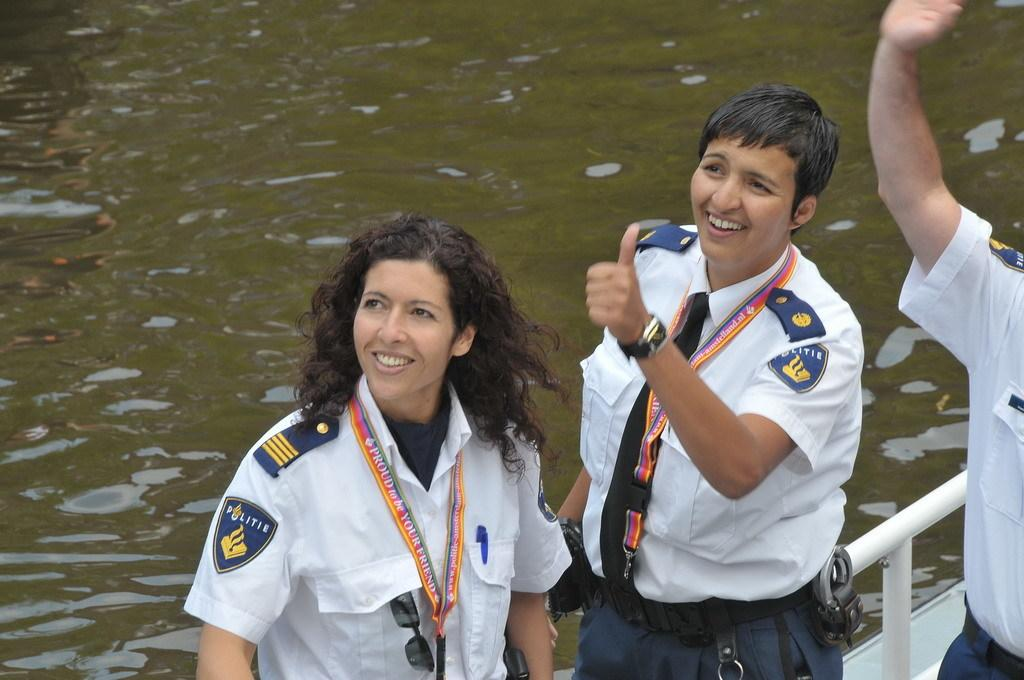What is the main subject of the image? The main subject of the image is a boat. Where is the boat located? The boat is on the water. How many people are on the boat? There are three persons standing on the boat. What type of cushion is used to decorate the sky in the image? There is no cushion present in the image, nor is there any decoration of the sky. 